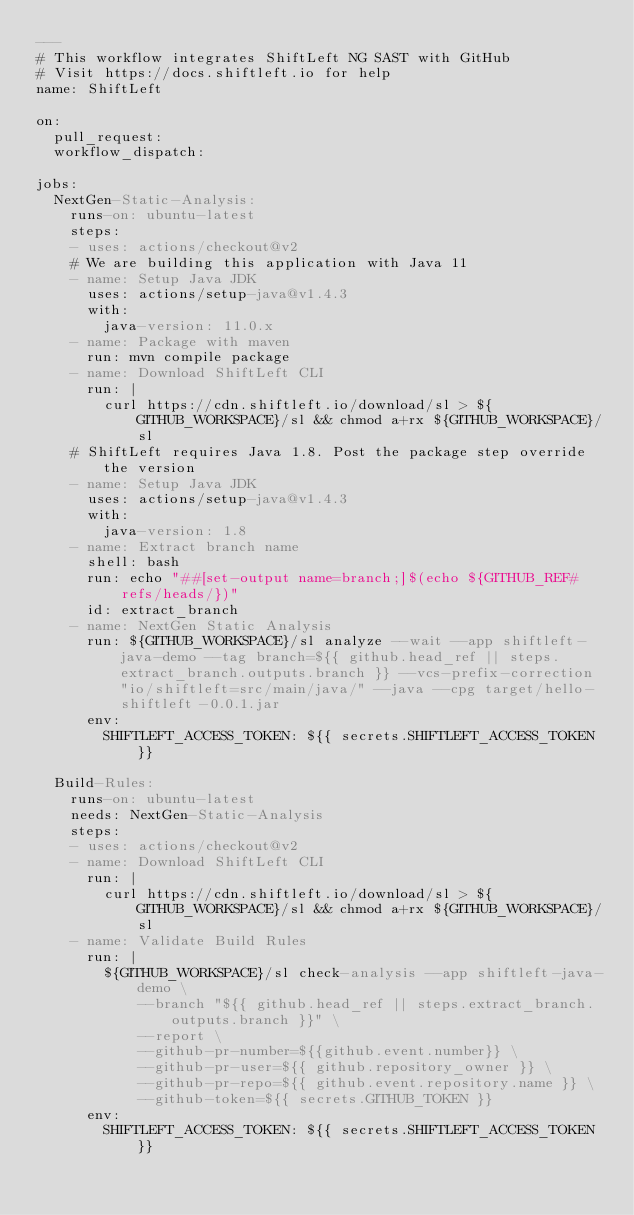Convert code to text. <code><loc_0><loc_0><loc_500><loc_500><_YAML_>---
# This workflow integrates ShiftLeft NG SAST with GitHub
# Visit https://docs.shiftleft.io for help
name: ShiftLeft

on:
  pull_request:
  workflow_dispatch:

jobs:
  NextGen-Static-Analysis:
    runs-on: ubuntu-latest
    steps:
    - uses: actions/checkout@v2
    # We are building this application with Java 11
    - name: Setup Java JDK
      uses: actions/setup-java@v1.4.3
      with:
        java-version: 11.0.x
    - name: Package with maven
      run: mvn compile package
    - name: Download ShiftLeft CLI
      run: |
        curl https://cdn.shiftleft.io/download/sl > ${GITHUB_WORKSPACE}/sl && chmod a+rx ${GITHUB_WORKSPACE}/sl
    # ShiftLeft requires Java 1.8. Post the package step override the version
    - name: Setup Java JDK
      uses: actions/setup-java@v1.4.3
      with:
        java-version: 1.8
    - name: Extract branch name
      shell: bash
      run: echo "##[set-output name=branch;]$(echo ${GITHUB_REF#refs/heads/})"
      id: extract_branch
    - name: NextGen Static Analysis
      run: ${GITHUB_WORKSPACE}/sl analyze --wait --app shiftleft-java-demo --tag branch=${{ github.head_ref || steps.extract_branch.outputs.branch }} --vcs-prefix-correction "io/shiftleft=src/main/java/" --java --cpg target/hello-shiftleft-0.0.1.jar
      env:
        SHIFTLEFT_ACCESS_TOKEN: ${{ secrets.SHIFTLEFT_ACCESS_TOKEN }}
        
  Build-Rules: 
    runs-on: ubuntu-latest
    needs: NextGen-Static-Analysis
    steps:
    - uses: actions/checkout@v2
    - name: Download ShiftLeft CLI
      run: |
        curl https://cdn.shiftleft.io/download/sl > ${GITHUB_WORKSPACE}/sl && chmod a+rx ${GITHUB_WORKSPACE}/sl
    - name: Validate Build Rules
      run: |
        ${GITHUB_WORKSPACE}/sl check-analysis --app shiftleft-java-demo \
            --branch "${{ github.head_ref || steps.extract_branch.outputs.branch }}" \
            --report \
            --github-pr-number=${{github.event.number}} \
            --github-pr-user=${{ github.repository_owner }} \
            --github-pr-repo=${{ github.event.repository.name }} \
            --github-token=${{ secrets.GITHUB_TOKEN }}
      env:
        SHIFTLEFT_ACCESS_TOKEN: ${{ secrets.SHIFTLEFT_ACCESS_TOKEN }}
         
  </code> 